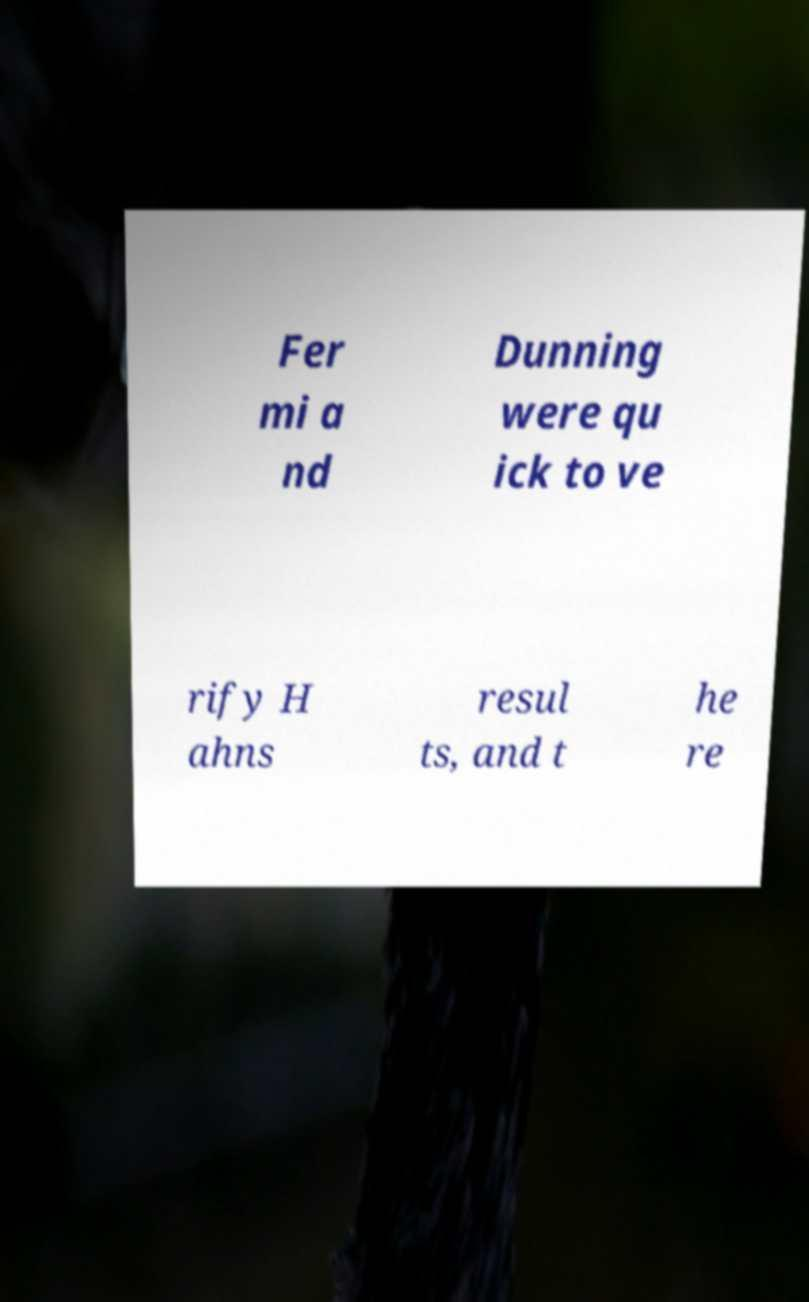I need the written content from this picture converted into text. Can you do that? Fer mi a nd Dunning were qu ick to ve rify H ahns resul ts, and t he re 